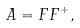Convert formula to latex. <formula><loc_0><loc_0><loc_500><loc_500>A = F F ^ { + } ,</formula> 